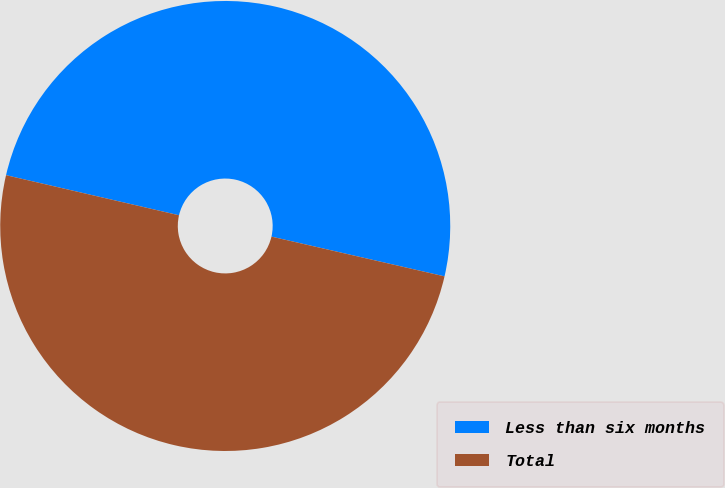Convert chart. <chart><loc_0><loc_0><loc_500><loc_500><pie_chart><fcel>Less than six months<fcel>Total<nl><fcel>49.97%<fcel>50.03%<nl></chart> 